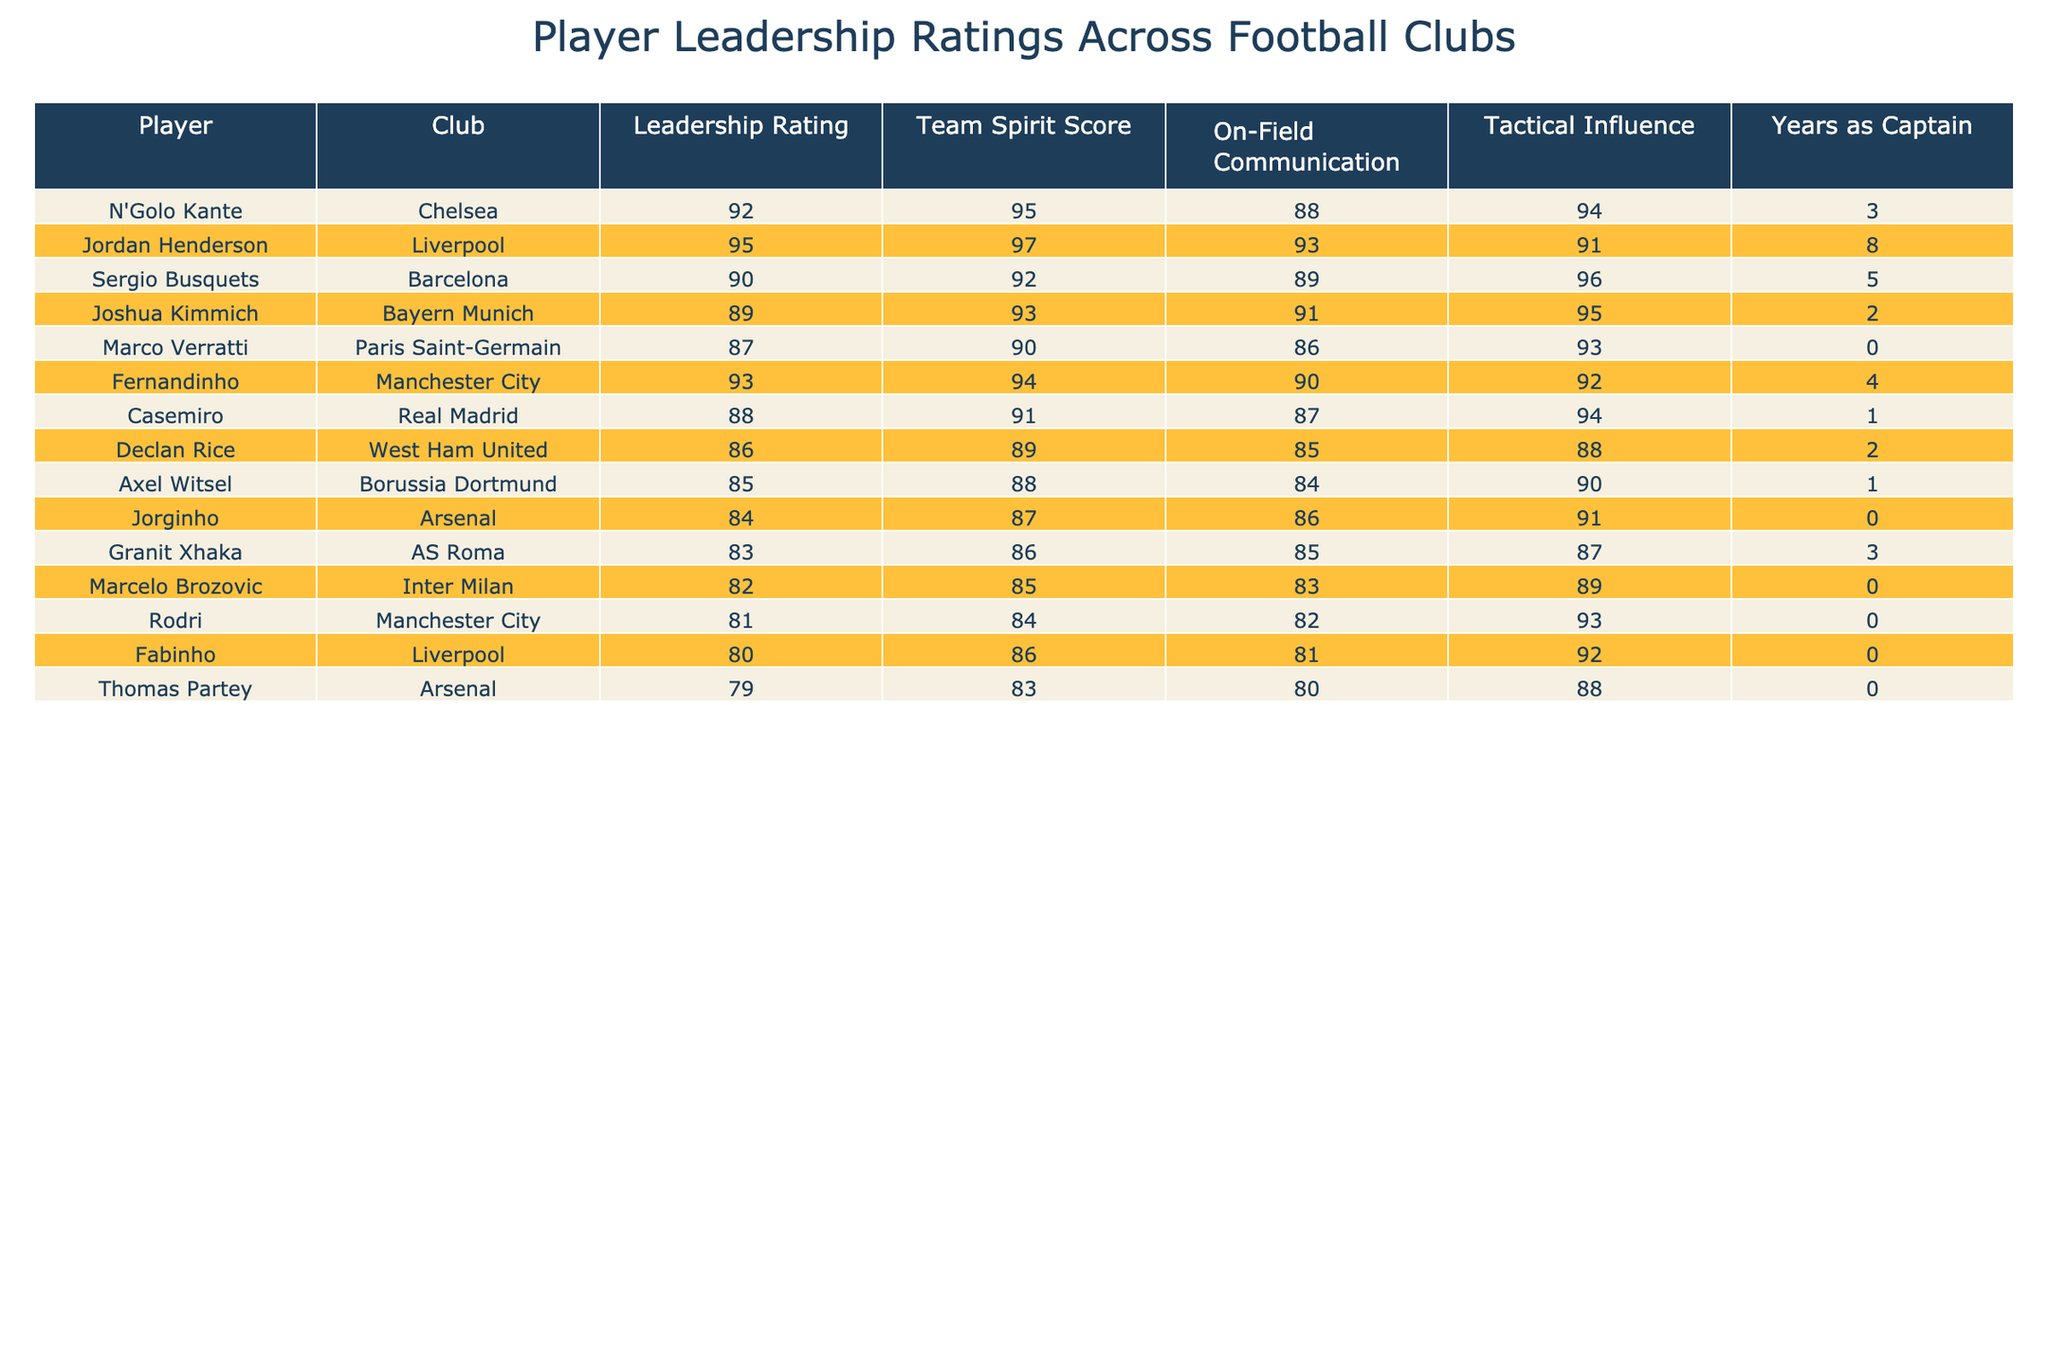What is the highest leadership rating in the table? The table shows various leadership ratings for different players. By scanning through the Leadership Rating column, I can see that Jordan Henderson has the highest rating at 95.
Answer: 95 Who has the lowest team spirit score? Looking at the Team Spirit Score column, Declan Rice has the lowest score of 86.
Answer: 86 How many players have a leadership rating of 90 or above? I can count the players with leadership ratings of 90 or above by checking the Leadership Rating column. The players are N'Golo Kante, Jordan Henderson, Sergio Busquets, and Fernandinho, totaling 4 players.
Answer: 4 Is Fernandinho a captain for more than 4 years? Referring to the Years as Captain column, Fernandinho has been a captain for 4 years, which is not more than 4, making the statement false.
Answer: False What is the average on-field communication score for the players listed? I will sum up all the On-Field Communication scores: 88 + 93 + 89 + 91 + 86 + 90 + 87 + 85 + 84 + 82 + 81 + 80 = 1020. There are 12 players, so the average is 1020 / 12 = 85.
Answer: 85 Which club has the player with the most years as captain? By checking the Years as Captain column, I see that Jordan Henderson from Liverpool has the highest score of 8 years, which indicates he has the most years as captain.
Answer: Liverpool What is the total leadership rating for players from Manchester City? For Manchester City, I will add the leadership ratings of Fernandinho (93) and Rodri (81), giving me a total of 93 + 81 = 174.
Answer: 174 Which player has a higher tactical influence, Casemiro or Jorginho? I compare the Tactical Influence scores: Casemiro has 94, while Jorginho has 91. Thus, Casemiro has a higher tactical influence.
Answer: Casemiro How does the team spirit score of players from Arsenal compare to those from Liverpool? The team spirit scores for Arsenal are 87 (Jorginho) and 83 (Thomas Partey), giving an average of (87 + 83) / 2 = 85. For Liverpool, the scores are 97 (Jordan Henderson) and 86 (Fabinho), giving an average of (97 + 86) / 2 = 91. Liverpool has a higher average score than Arsenal.
Answer: Liverpool Which player has the highest tactical influence among those who have never been a captain? Looking at the Tactical Influence column for players who have never been captain (Marco Verratti, Jorginho, Rodri, and others), I find that Rodri has the highest tactical influence score of 93.
Answer: Rodri 